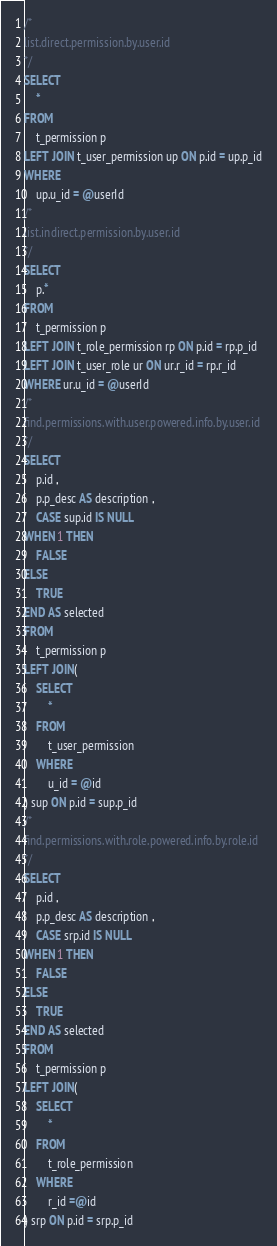<code> <loc_0><loc_0><loc_500><loc_500><_SQL_>/*
list.direct.permission.by.user.id
*/
SELECT
	*
FROM
	t_permission p
LEFT JOIN t_user_permission up ON p.id = up.p_id
WHERE
	up.u_id = @userId
/*
list.indirect.permission.by.user.id
*/
SELECT
	p.*
FROM
	t_permission p
LEFT JOIN t_role_permission rp ON p.id = rp.p_id
LEFT JOIN t_user_role ur ON ur.r_id = rp.r_id
WHERE ur.u_id = @userId
/*
find.permissions.with.user.powered.info.by.user.id
*/
SELECT
	p.id ,
	p.p_desc AS description ,
	CASE sup.id IS NULL
WHEN 1 THEN
	FALSE
ELSE
	TRUE
END AS selected
FROM
	t_permission p
LEFT JOIN(
	SELECT
		*
	FROM
		t_user_permission
	WHERE
		u_id = @id
) sup ON p.id = sup.p_id
/*
find.permissions.with.role.powered.info.by.role.id
*/
SELECT
	p.id ,
	p.p_desc AS description ,
	CASE srp.id IS NULL
WHEN 1 THEN
	FALSE
ELSE
	TRUE
END AS selected
FROM
	t_permission p
LEFT JOIN(
	SELECT
		*
	FROM
		t_role_permission
	WHERE
		r_id =@id
) srp ON p.id = srp.p_id</code> 